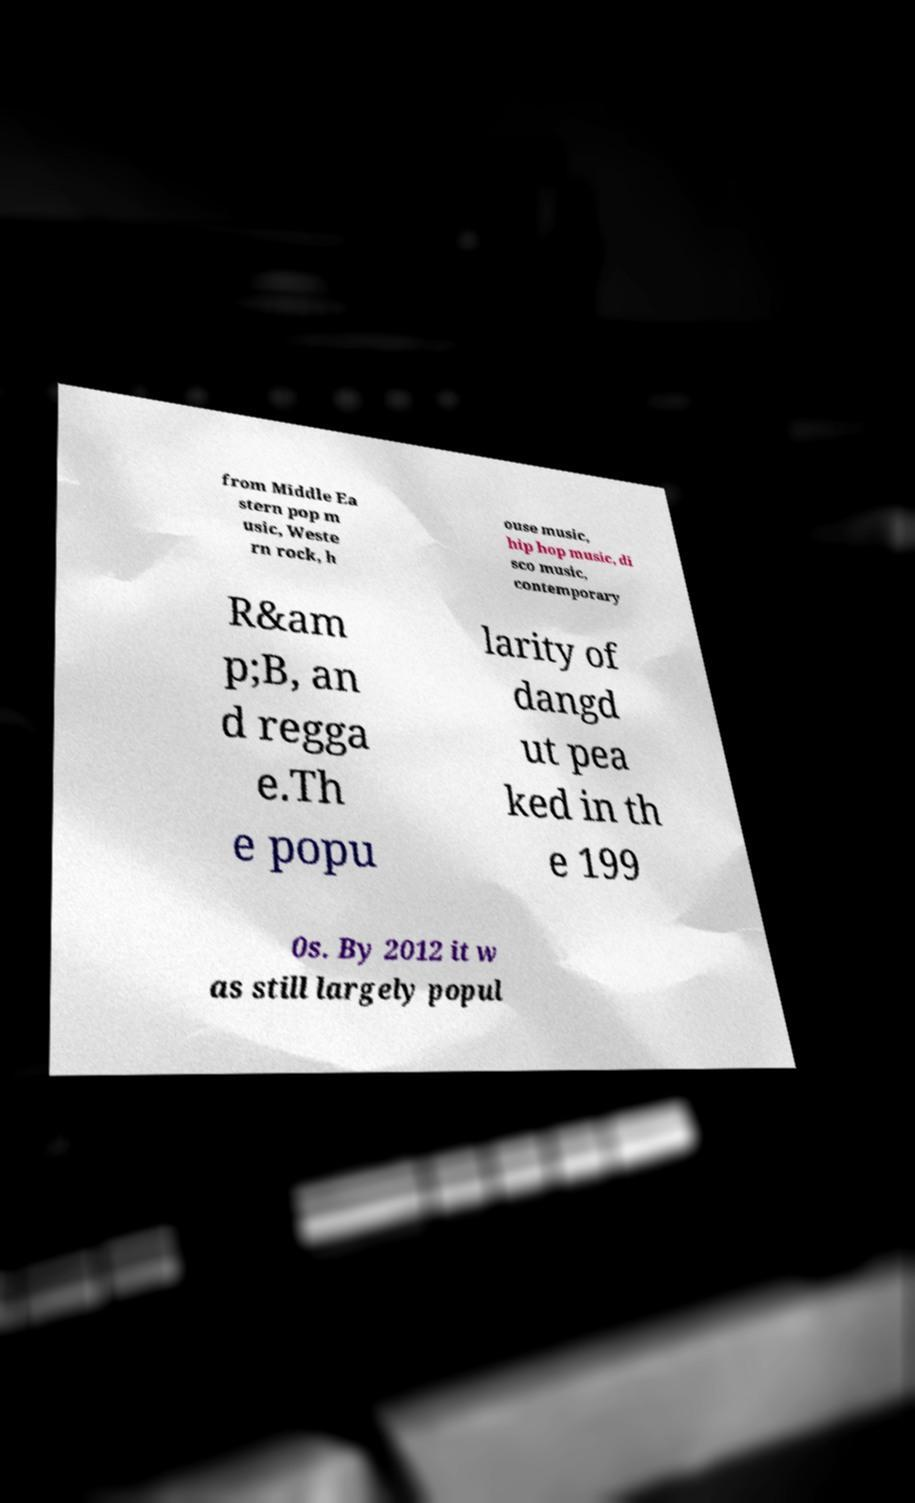What messages or text are displayed in this image? I need them in a readable, typed format. from Middle Ea stern pop m usic, Weste rn rock, h ouse music, hip hop music, di sco music, contemporary R&am p;B, an d regga e.Th e popu larity of dangd ut pea ked in th e 199 0s. By 2012 it w as still largely popul 